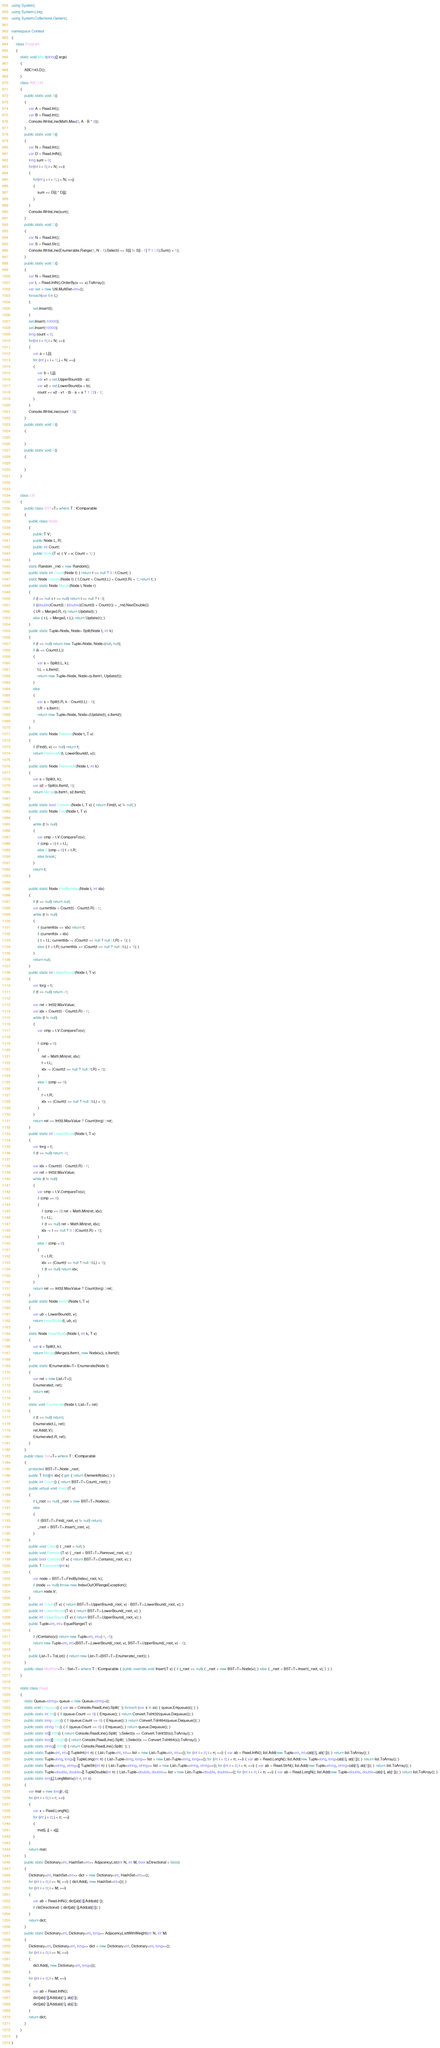Convert code to text. <code><loc_0><loc_0><loc_500><loc_500><_C#_>using System;
using System.Linq;
using System.Collections.Generic;

namespace Contest
{
    class Program
    {
        static void Main(string[] args)
        {
            ABC143.D();
        }
        class ABC143
        {
            public static void A()
            {
                var A = Read.Int();
                var B = Read.Int();
                Console.WriteLine(Math.Max(0, A - B * 2));
            }
            public static void B()
            {
                var N = Read.Int();
                var D = Read.IntN();
                long sum = 0;
                for(int i = 0; i < N; ++i)
                {
                    for(int j = i + 1; j < N; ++j)
                    {
                        sum += D[i] * D[j];
                    }
                }
                Console.WriteLine(sum);
            }
            public static void C()
            {
                var N = Read.Int();
                var S = Read.Str();
                Console.WriteLine(Enumerable.Range(1, N - 1).Select(i => S[i] != S[i - 1] ? 1 : 0).Sum() + 1);
            }
            public static void D()
            {
                var N = Read.Int();
                var L = Read.IntN().OrderBy(x => x).ToArray();
                var set = new Util.MultiSet<int>();
                foreach(var l in L)
                {
                    set.Insert(l);
                }
                set.Insert(-10000);
                set.Insert(10000);
                long count = 0;
                for(int i = 0; i < N; ++i)
                {
                    var a = L[i];
                    for (int j = i + 1; j < N; ++j)
                    {
                        var b = L[j];
                        var v1 = set.UpperBound(b - a);
                        var v2 = set.LowerBound(a + b);
                        count += v2 - v1 - (b - a < a ? 1 : 0) - 1;
                    }
                }
                Console.WriteLine(count / 3);
            }
            public static void E()
            {

            }
            public static void F()
            {

            }
        }


        class Util
        {
            public class BST<T> where T : IComparable
            {
                public class Node
                {
                    public T V;
                    public Node L, R;
                    public int Count;
                    public Node(T v) { V = v; Count = 1; }
                }
                static Random _rnd = new Random();
                public static int Count(Node t) { return t == null ? 0 : t.Count; }
                static Node Update(Node t) { t.Count = Count(t.L) + Count(t.R) + 1; return t; }
                public static Node Merge(Node l, Node r)
                {
                    if (l == null || r == null) return l == null ? r : l;
                    if ((double)Count(l) / (double)(Count(l) + Count(r)) > _rnd.NextDouble())
                    { l.R = Merge(l.R, r); return Update(l); }
                    else { r.L = Merge(l, r.L); return Update(r); }
                }
                public static Tuple<Node, Node> Split(Node t, int k)
                {
                    if (t == null) return new Tuple<Node, Node>(null, null);
                    if (k <= Count(t.L))
                    {
                        var s = Split(t.L, k);
                        t.L = s.Item2;
                        return new Tuple<Node, Node>(s.Item1, Update(t));
                    }
                    else
                    {
                        var s = Split(t.R, k - Count(t.L) - 1);
                        t.R = s.Item1;
                        return new Tuple<Node, Node>(Update(t), s.Item2);
                    }
                }
                public static Node Remove(Node t, T v)
                {
                    if (Find(t, v) == null) return t;
                    return RemoveAt(t, LowerBound(t, v));
                }
                public static Node RemoveAt(Node t, int k)
                {
                    var s = Split(t, k);
                    var s2 = Split(s.Item2, 1);
                    return Merge(s.Item1, s2.Item2);
                }
                public static bool Contains(Node t, T v) { return Find(t, v) != null; }
                public static Node Find(Node t, T v)
                {
                    while (t != null)
                    {
                        var cmp = t.V.CompareTo(v);
                        if (cmp > 0) t = t.L;
                        else if (cmp < 0) t = t.R;
                        else break;
                    }
                    return t;
                }

                public static Node FindByIndex(Node t, int idx)
                {
                    if (t == null) return null;
                    var currentIdx = Count(t) - Count(t.R) - 1;
                    while (t != null)
                    {
                        if (currentIdx == idx) return t;
                        if (currentIdx > idx)
                        { t = t.L; currentIdx -= (Count(t == null ? null : t.R) + 1); }
                        else { t = t.R; currentIdx += (Count(t == null ? null : t.L) + 1); }
                    }
                    return null;
                }
                public static int UpperBound(Node t, T v)
                {
                    var torg = t;
                    if (t == null) return -1;

                    var ret = Int32.MaxValue;
                    var idx = Count(t) - Count(t.R) - 1;
                    while (t != null)
                    {
                        var cmp = t.V.CompareTo(v);

                        if (cmp > 0)
                        {
                            ret = Math.Min(ret, idx);
                            t = t.L;
                            idx -= (Count(t == null ? null : t.R) + 1);
                        }
                        else if (cmp <= 0)
                        {
                            t = t.R;
                            idx += (Count(t == null ? null : t.L) + 1);
                        }
                    }
                    return ret == Int32.MaxValue ? Count(torg) : ret;
                }
                public static int LowerBound(Node t, T v)
                {
                    var torg = t;
                    if (t == null) return -1;

                    var idx = Count(t) - Count(t.R) - 1;
                    var ret = Int32.MaxValue;
                    while (t != null)
                    {
                        var cmp = t.V.CompareTo(v);
                        if (cmp >= 0)
                        {
                            if (cmp == 0) ret = Math.Min(ret, idx);
                            t = t.L;
                            if (t == null) ret = Math.Min(ret, idx);
                            idx -= t == null ? 0 : (Count(t.R) + 1);
                        }
                        else if (cmp < 0)
                        {
                            t = t.R;
                            idx += (Count(t == null ? null : t.L) + 1);
                            if (t == null) return idx;
                        }
                    }
                    return ret == Int32.MaxValue ? Count(torg) : ret;
                }
                public static Node Insert(Node t, T v)
                {
                    var ub = LowerBound(t, v);
                    return InsertByIdx(t, ub, v);
                }
                static Node InsertByIdx(Node t, int k, T v)
                {
                    var s = Split(t, k);
                    return Merge(Merge(s.Item1, new Node(v)), s.Item2);
                }
                public static IEnumerable<T> Enumerate(Node t)
                {
                    var ret = new List<T>();
                    Enumerate(t, ret);
                    return ret;
                }
                static void Enumerate(Node t, List<T> ret)
                {
                    if (t == null) return;
                    Enumerate(t.L, ret);
                    ret.Add(t.V);
                    Enumerate(t.R, ret);
                }
            }
            public class Set<T> where T : IComparable
            {
                protected BST<T>.Node _root;
                public T this[int idx] { get { return ElementAt(idx); } }
                public int Count() { return BST<T>.Count(_root); }
                public virtual void Insert(T v)
                {
                    if (_root == null) _root = new BST<T>.Node(v);
                    else
                    {
                        if (BST<T>.Find(_root, v) != null) return;
                        _root = BST<T>.Insert(_root, v);
                    }
                }
                public void Clear() { _root = null; }
                public void Remove(T v) { _root = BST<T>.Remove(_root, v); }
                public bool Contains(T v) { return BST<T>.Contains(_root, v); }
                public T ElementAt(int k)
                {
                    var node = BST<T>.FindByIndex(_root, k);
                    if (node == null) throw new IndexOutOfRangeException();
                    return node.V;
                }
                public int Count(T v) { return BST<T>.UpperBound(_root, v) - BST<T>.LowerBound(_root, v); }
                public int LowerBound(T v) { return BST<T>.LowerBound(_root, v); }
                public int UpperBound(T v) { return BST<T>.UpperBound(_root, v); }
                public Tuple<int, int> EqualRange(T v)
                {
                    if (!Contains(v)) return new Tuple<int, int>(-1, -1);
                    return new Tuple<int, int>(BST<T>.LowerBound(_root, v), BST<T>.UpperBound(_root, v) - 1);
                }
                public List<T> ToList() { return new List<T>(BST<T>.Enumerate(_root)); }
            }
            public class MultiSet<T> : Set<T> where T : IComparable { public override void Insert(T v) { if (_root == null) { _root = new BST<T>.Node(v); } else { _root = BST<T>.Insert(_root, v); } } }
        }

        static class Read
        {
            static Queue<string> queue = new Queue<string>();
            static void Enqueue() { var ss = Console.ReadLine().Split(' '); foreach (var s in ss) { queue.Enqueue(s); } }
            public static int Int() { if (queue.Count == 0) { Enqueue(); } return Convert.ToInt32(queue.Dequeue()); }
            public static long Long() { if (queue.Count == 0) { Enqueue(); } return Convert.ToInt64(queue.Dequeue()); }
            public static string Str() { if (queue.Count == 0) { Enqueue(); } return queue.Dequeue(); }
            public static int[] IntN() { return Console.ReadLine().Split(' ').Select(s => Convert.ToInt32(s)).ToArray(); }
            public static long[] LongN() { return Console.ReadLine().Split(' ').Select(s => Convert.ToInt64(s)).ToArray(); }
            public static string[] StrN() { return Console.ReadLine().Split(' '); }
            public static Tuple<int, int>[] TupleInt(int n) { List<Tuple<int, int>> list = new List<Tuple<int, int>>(); for (int i = 0; i < n; ++i) { var ab = Read.IntN(); list.Add(new Tuple<int, int>(ab[0], ab[1])); } return list.ToArray(); }
            public static Tuple<long, long>[] TupleLong(int n) { List<Tuple<long, long>> list = new List<Tuple<long, long>>(); for (int i = 0; i < n; ++i) { var ab = Read.LongN(); list.Add(new Tuple<long, long>(ab[0], ab[1])); } return list.ToArray(); }
            public static Tuple<string, string>[] TupleStr(int n) { List<Tuple<string, string>> list = new List<Tuple<string, string>>(); for (int i = 0; i < n; ++i) { var ab = Read.StrN(); list.Add(new Tuple<string, string>(ab[0], ab[1])); } return list.ToArray(); }
            public static Tuple<double, double>[] TupleDouble(int n) { List<Tuple<double, double>> list = new List<Tuple<double, double>>(); for (int i = 0; i < n; ++i) { var ab = Read.LongN(); list.Add(new Tuple<double, double>(ab[0], ab[1])); } return list.ToArray(); }
            public static long[,] LongMatrix(int r, int c)
            {
                var mat = new long[r, c];
                for (int i = 0; i < r; ++i)
                {
                    var x = Read.LongN();
                    for (int j = 0; j < c; ++j)
                    {
                        mat[i, j] = x[j];
                    }
                }
                return mat;
            }
            public static Dictionary<int, HashSet<int>> AdjacencyList(int N, int M, bool isDirectional = false)
            {
                Dictionary<int, HashSet<int>> dict = new Dictionary<int, HashSet<int>>();
                for (int i = 0; i <= N; ++i) { dict.Add(i, new HashSet<int>()); }
                for (int i = 0; i < M; ++i)
                {
                    var ab = Read.IntN(); dict[ab[0]].Add(ab[1]);
                    if (!isDirectional) { dict[ab[1]].Add(ab[0]); }
                }
                return dict;
            }
            public static Dictionary<int, Dictionary<int, long>> AdjacencyListWithWeight(int N, int M)
            {
                Dictionary<int, Dictionary<int, long>> dict = new Dictionary<int, Dictionary<int, long>>();
                for (int i = 0; i <= N; ++i)
                {
                    dict.Add(i, new Dictionary<int, long>());
                }
                for (int i = 0; i < M; ++i)
                {
                    var ab = Read.IntN();
                    dict[ab[0]].Add(ab[1], ab[2]);
                    dict[ab[1]].Add(ab[0], ab[2]);
                }
                return dict;
            }
        }
    }
}
</code> 